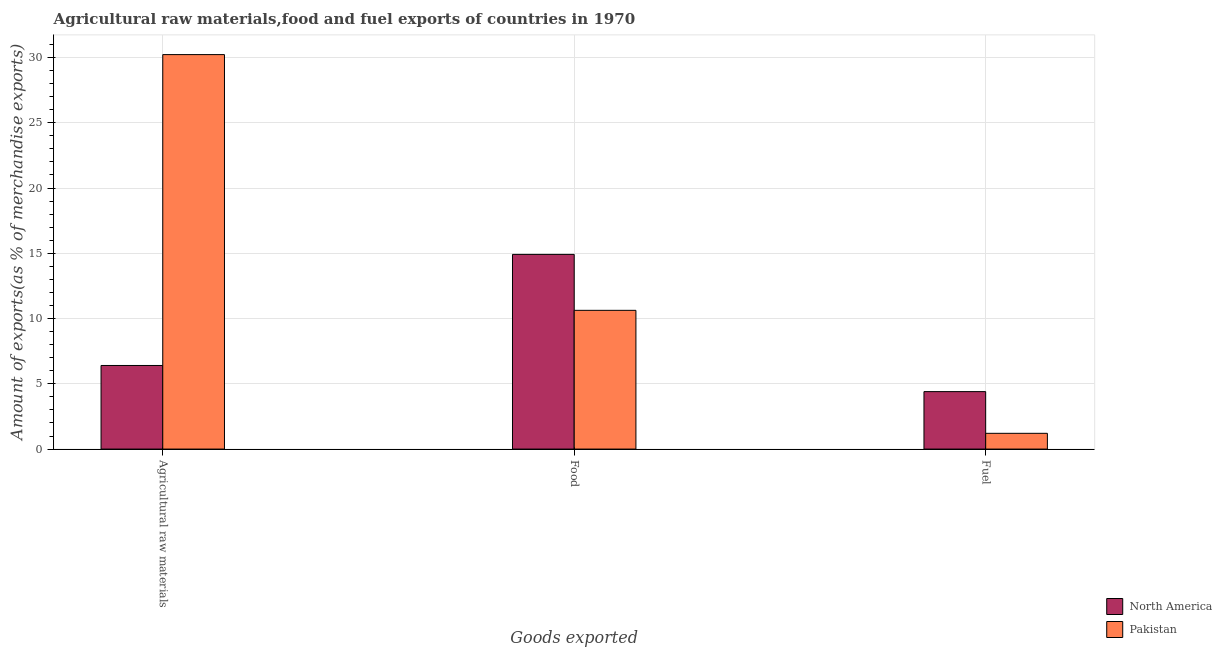How many different coloured bars are there?
Your response must be concise. 2. Are the number of bars per tick equal to the number of legend labels?
Offer a very short reply. Yes. How many bars are there on the 3rd tick from the left?
Your response must be concise. 2. How many bars are there on the 1st tick from the right?
Give a very brief answer. 2. What is the label of the 1st group of bars from the left?
Provide a succinct answer. Agricultural raw materials. What is the percentage of fuel exports in Pakistan?
Make the answer very short. 1.21. Across all countries, what is the maximum percentage of fuel exports?
Ensure brevity in your answer.  4.4. Across all countries, what is the minimum percentage of fuel exports?
Provide a succinct answer. 1.21. In which country was the percentage of food exports minimum?
Your response must be concise. Pakistan. What is the total percentage of food exports in the graph?
Offer a very short reply. 25.54. What is the difference between the percentage of fuel exports in North America and that in Pakistan?
Provide a short and direct response. 3.19. What is the difference between the percentage of fuel exports in North America and the percentage of food exports in Pakistan?
Your answer should be compact. -6.23. What is the average percentage of food exports per country?
Your answer should be very brief. 12.77. What is the difference between the percentage of raw materials exports and percentage of food exports in Pakistan?
Keep it short and to the point. 19.59. In how many countries, is the percentage of raw materials exports greater than 9 %?
Ensure brevity in your answer.  1. What is the ratio of the percentage of fuel exports in North America to that in Pakistan?
Provide a short and direct response. 3.64. Is the difference between the percentage of raw materials exports in North America and Pakistan greater than the difference between the percentage of food exports in North America and Pakistan?
Your answer should be very brief. No. What is the difference between the highest and the second highest percentage of fuel exports?
Your answer should be compact. 3.19. What is the difference between the highest and the lowest percentage of food exports?
Give a very brief answer. 4.29. In how many countries, is the percentage of fuel exports greater than the average percentage of fuel exports taken over all countries?
Ensure brevity in your answer.  1. Is the sum of the percentage of fuel exports in Pakistan and North America greater than the maximum percentage of food exports across all countries?
Offer a very short reply. No. What does the 2nd bar from the left in Fuel represents?
Give a very brief answer. Pakistan. What does the 2nd bar from the right in Food represents?
Your answer should be very brief. North America. How many bars are there?
Your answer should be compact. 6. How many countries are there in the graph?
Your answer should be very brief. 2. What is the difference between two consecutive major ticks on the Y-axis?
Give a very brief answer. 5. Does the graph contain any zero values?
Provide a short and direct response. No. Where does the legend appear in the graph?
Your answer should be very brief. Bottom right. How many legend labels are there?
Offer a very short reply. 2. What is the title of the graph?
Offer a terse response. Agricultural raw materials,food and fuel exports of countries in 1970. Does "Venezuela" appear as one of the legend labels in the graph?
Offer a very short reply. No. What is the label or title of the X-axis?
Make the answer very short. Goods exported. What is the label or title of the Y-axis?
Offer a very short reply. Amount of exports(as % of merchandise exports). What is the Amount of exports(as % of merchandise exports) of North America in Agricultural raw materials?
Give a very brief answer. 6.4. What is the Amount of exports(as % of merchandise exports) of Pakistan in Agricultural raw materials?
Your answer should be very brief. 30.22. What is the Amount of exports(as % of merchandise exports) in North America in Food?
Ensure brevity in your answer.  14.92. What is the Amount of exports(as % of merchandise exports) in Pakistan in Food?
Your answer should be compact. 10.63. What is the Amount of exports(as % of merchandise exports) of North America in Fuel?
Provide a succinct answer. 4.4. What is the Amount of exports(as % of merchandise exports) of Pakistan in Fuel?
Your response must be concise. 1.21. Across all Goods exported, what is the maximum Amount of exports(as % of merchandise exports) in North America?
Your response must be concise. 14.92. Across all Goods exported, what is the maximum Amount of exports(as % of merchandise exports) of Pakistan?
Ensure brevity in your answer.  30.22. Across all Goods exported, what is the minimum Amount of exports(as % of merchandise exports) of North America?
Offer a very short reply. 4.4. Across all Goods exported, what is the minimum Amount of exports(as % of merchandise exports) of Pakistan?
Your answer should be compact. 1.21. What is the total Amount of exports(as % of merchandise exports) of North America in the graph?
Your answer should be compact. 25.72. What is the total Amount of exports(as % of merchandise exports) in Pakistan in the graph?
Your response must be concise. 42.06. What is the difference between the Amount of exports(as % of merchandise exports) of North America in Agricultural raw materials and that in Food?
Give a very brief answer. -8.51. What is the difference between the Amount of exports(as % of merchandise exports) in Pakistan in Agricultural raw materials and that in Food?
Your answer should be very brief. 19.59. What is the difference between the Amount of exports(as % of merchandise exports) of North America in Agricultural raw materials and that in Fuel?
Provide a short and direct response. 2. What is the difference between the Amount of exports(as % of merchandise exports) in Pakistan in Agricultural raw materials and that in Fuel?
Provide a short and direct response. 29.01. What is the difference between the Amount of exports(as % of merchandise exports) in North America in Food and that in Fuel?
Your answer should be compact. 10.51. What is the difference between the Amount of exports(as % of merchandise exports) of Pakistan in Food and that in Fuel?
Offer a very short reply. 9.42. What is the difference between the Amount of exports(as % of merchandise exports) of North America in Agricultural raw materials and the Amount of exports(as % of merchandise exports) of Pakistan in Food?
Ensure brevity in your answer.  -4.23. What is the difference between the Amount of exports(as % of merchandise exports) in North America in Agricultural raw materials and the Amount of exports(as % of merchandise exports) in Pakistan in Fuel?
Give a very brief answer. 5.2. What is the difference between the Amount of exports(as % of merchandise exports) in North America in Food and the Amount of exports(as % of merchandise exports) in Pakistan in Fuel?
Offer a terse response. 13.71. What is the average Amount of exports(as % of merchandise exports) in North America per Goods exported?
Offer a very short reply. 8.57. What is the average Amount of exports(as % of merchandise exports) of Pakistan per Goods exported?
Offer a terse response. 14.02. What is the difference between the Amount of exports(as % of merchandise exports) in North America and Amount of exports(as % of merchandise exports) in Pakistan in Agricultural raw materials?
Your answer should be compact. -23.82. What is the difference between the Amount of exports(as % of merchandise exports) of North America and Amount of exports(as % of merchandise exports) of Pakistan in Food?
Keep it short and to the point. 4.29. What is the difference between the Amount of exports(as % of merchandise exports) of North America and Amount of exports(as % of merchandise exports) of Pakistan in Fuel?
Make the answer very short. 3.19. What is the ratio of the Amount of exports(as % of merchandise exports) in North America in Agricultural raw materials to that in Food?
Provide a succinct answer. 0.43. What is the ratio of the Amount of exports(as % of merchandise exports) of Pakistan in Agricultural raw materials to that in Food?
Offer a terse response. 2.84. What is the ratio of the Amount of exports(as % of merchandise exports) of North America in Agricultural raw materials to that in Fuel?
Ensure brevity in your answer.  1.46. What is the ratio of the Amount of exports(as % of merchandise exports) in Pakistan in Agricultural raw materials to that in Fuel?
Ensure brevity in your answer.  25.03. What is the ratio of the Amount of exports(as % of merchandise exports) of North America in Food to that in Fuel?
Your answer should be very brief. 3.39. What is the ratio of the Amount of exports(as % of merchandise exports) in Pakistan in Food to that in Fuel?
Provide a short and direct response. 8.8. What is the difference between the highest and the second highest Amount of exports(as % of merchandise exports) of North America?
Your response must be concise. 8.51. What is the difference between the highest and the second highest Amount of exports(as % of merchandise exports) in Pakistan?
Your answer should be compact. 19.59. What is the difference between the highest and the lowest Amount of exports(as % of merchandise exports) of North America?
Offer a terse response. 10.51. What is the difference between the highest and the lowest Amount of exports(as % of merchandise exports) of Pakistan?
Your response must be concise. 29.01. 